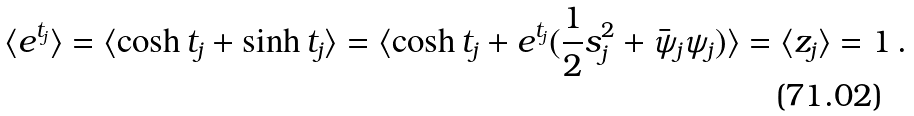<formula> <loc_0><loc_0><loc_500><loc_500>\langle e ^ { t _ { j } } \rangle = \langle \cosh t _ { j } + \sinh t _ { j } \rangle = \langle \cosh t _ { j } + e ^ { t _ { j } } ( { \frac { 1 } { 2 } } s _ { j } ^ { 2 } + \bar { \psi } _ { j } \psi _ { j } ) \rangle = \langle z _ { j } \rangle = 1 \, .</formula> 